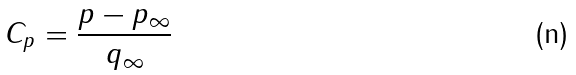<formula> <loc_0><loc_0><loc_500><loc_500>C _ { p } = { \frac { p - p _ { \infty } } { q _ { \infty } } }</formula> 